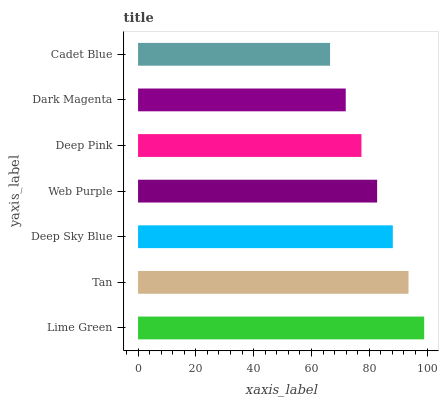Is Cadet Blue the minimum?
Answer yes or no. Yes. Is Lime Green the maximum?
Answer yes or no. Yes. Is Tan the minimum?
Answer yes or no. No. Is Tan the maximum?
Answer yes or no. No. Is Lime Green greater than Tan?
Answer yes or no. Yes. Is Tan less than Lime Green?
Answer yes or no. Yes. Is Tan greater than Lime Green?
Answer yes or no. No. Is Lime Green less than Tan?
Answer yes or no. No. Is Web Purple the high median?
Answer yes or no. Yes. Is Web Purple the low median?
Answer yes or no. Yes. Is Deep Sky Blue the high median?
Answer yes or no. No. Is Deep Sky Blue the low median?
Answer yes or no. No. 